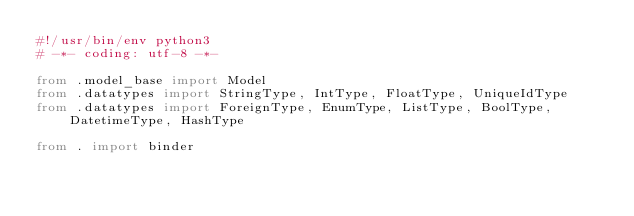Convert code to text. <code><loc_0><loc_0><loc_500><loc_500><_Python_>#!/usr/bin/env python3
# -*- coding: utf-8 -*-

from .model_base import Model
from .datatypes import StringType, IntType, FloatType, UniqueIdType
from .datatypes import ForeignType, EnumType, ListType, BoolType, DatetimeType, HashType

from . import binder
</code> 